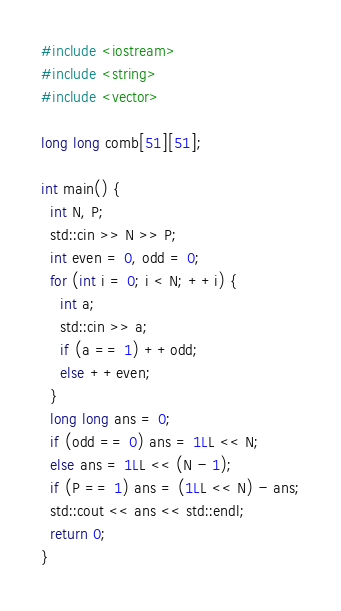<code> <loc_0><loc_0><loc_500><loc_500><_C++_>#include <iostream>
#include <string>
#include <vector>

long long comb[51][51];

int main() {
  int N, P;
  std::cin >> N >> P;
  int even = 0, odd = 0;
  for (int i = 0; i < N; ++i) {
    int a;
    std::cin >> a;
    if (a == 1) ++odd;
    else ++even;
  }
  long long ans = 0;
  if (odd == 0) ans = 1LL << N;
  else ans = 1LL << (N - 1);
  if (P == 1) ans = (1LL << N) - ans;
  std::cout << ans << std::endl;
  return 0;
}
</code> 